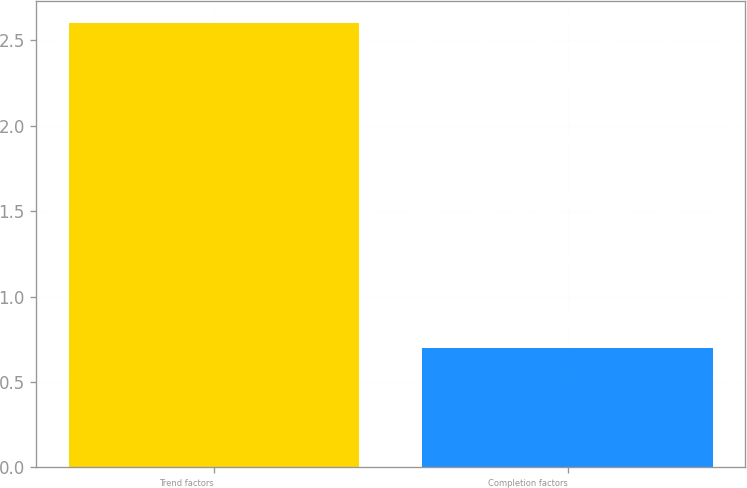Convert chart. <chart><loc_0><loc_0><loc_500><loc_500><bar_chart><fcel>Trend factors<fcel>Completion factors<nl><fcel>2.6<fcel>0.7<nl></chart> 